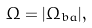<formula> <loc_0><loc_0><loc_500><loc_500>\Omega = | \Omega _ { b a } | ,</formula> 